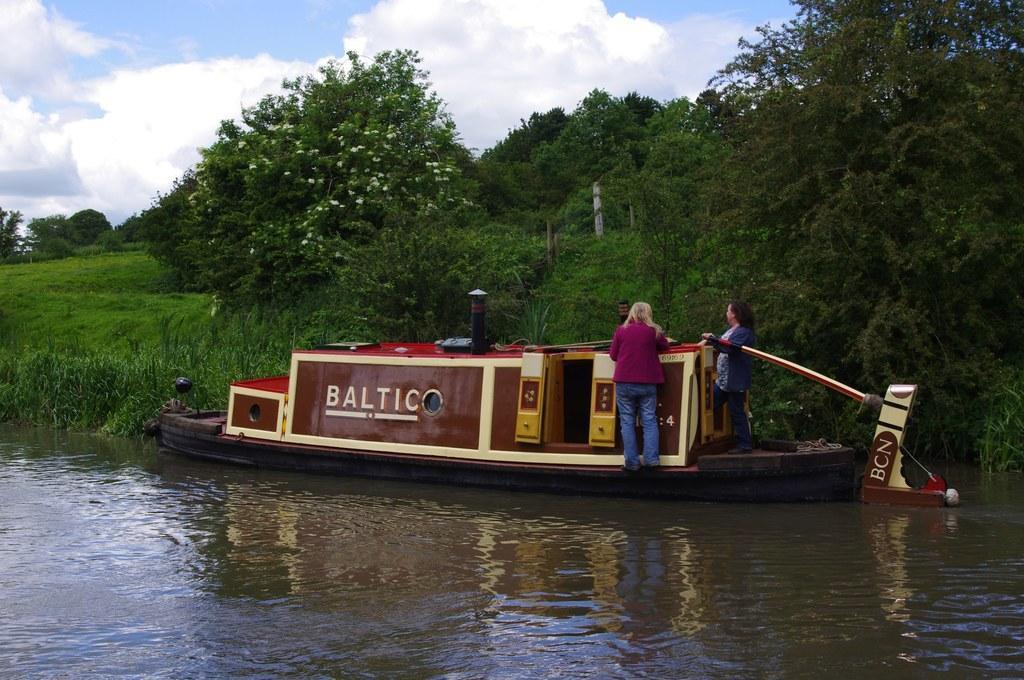Please provide a concise description of this image. In the image we can see two women standing and wearing clothes. We can even see there is a boat in the water. Here we can see grass, plants, trees and the cloudy sky. 